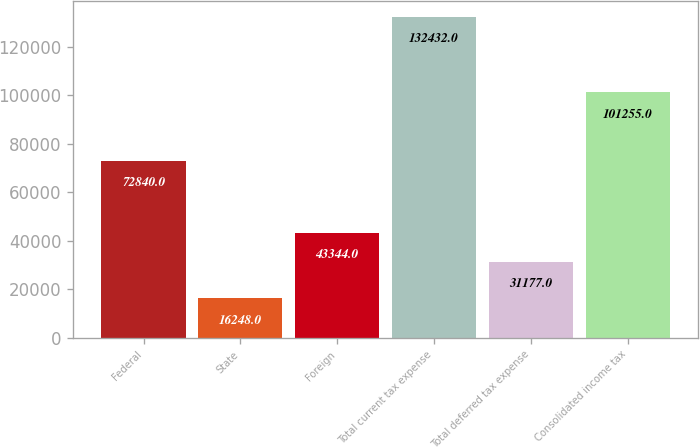Convert chart. <chart><loc_0><loc_0><loc_500><loc_500><bar_chart><fcel>Federal<fcel>State<fcel>Foreign<fcel>Total current tax expense<fcel>Total deferred tax expense<fcel>Consolidated income tax<nl><fcel>72840<fcel>16248<fcel>43344<fcel>132432<fcel>31177<fcel>101255<nl></chart> 